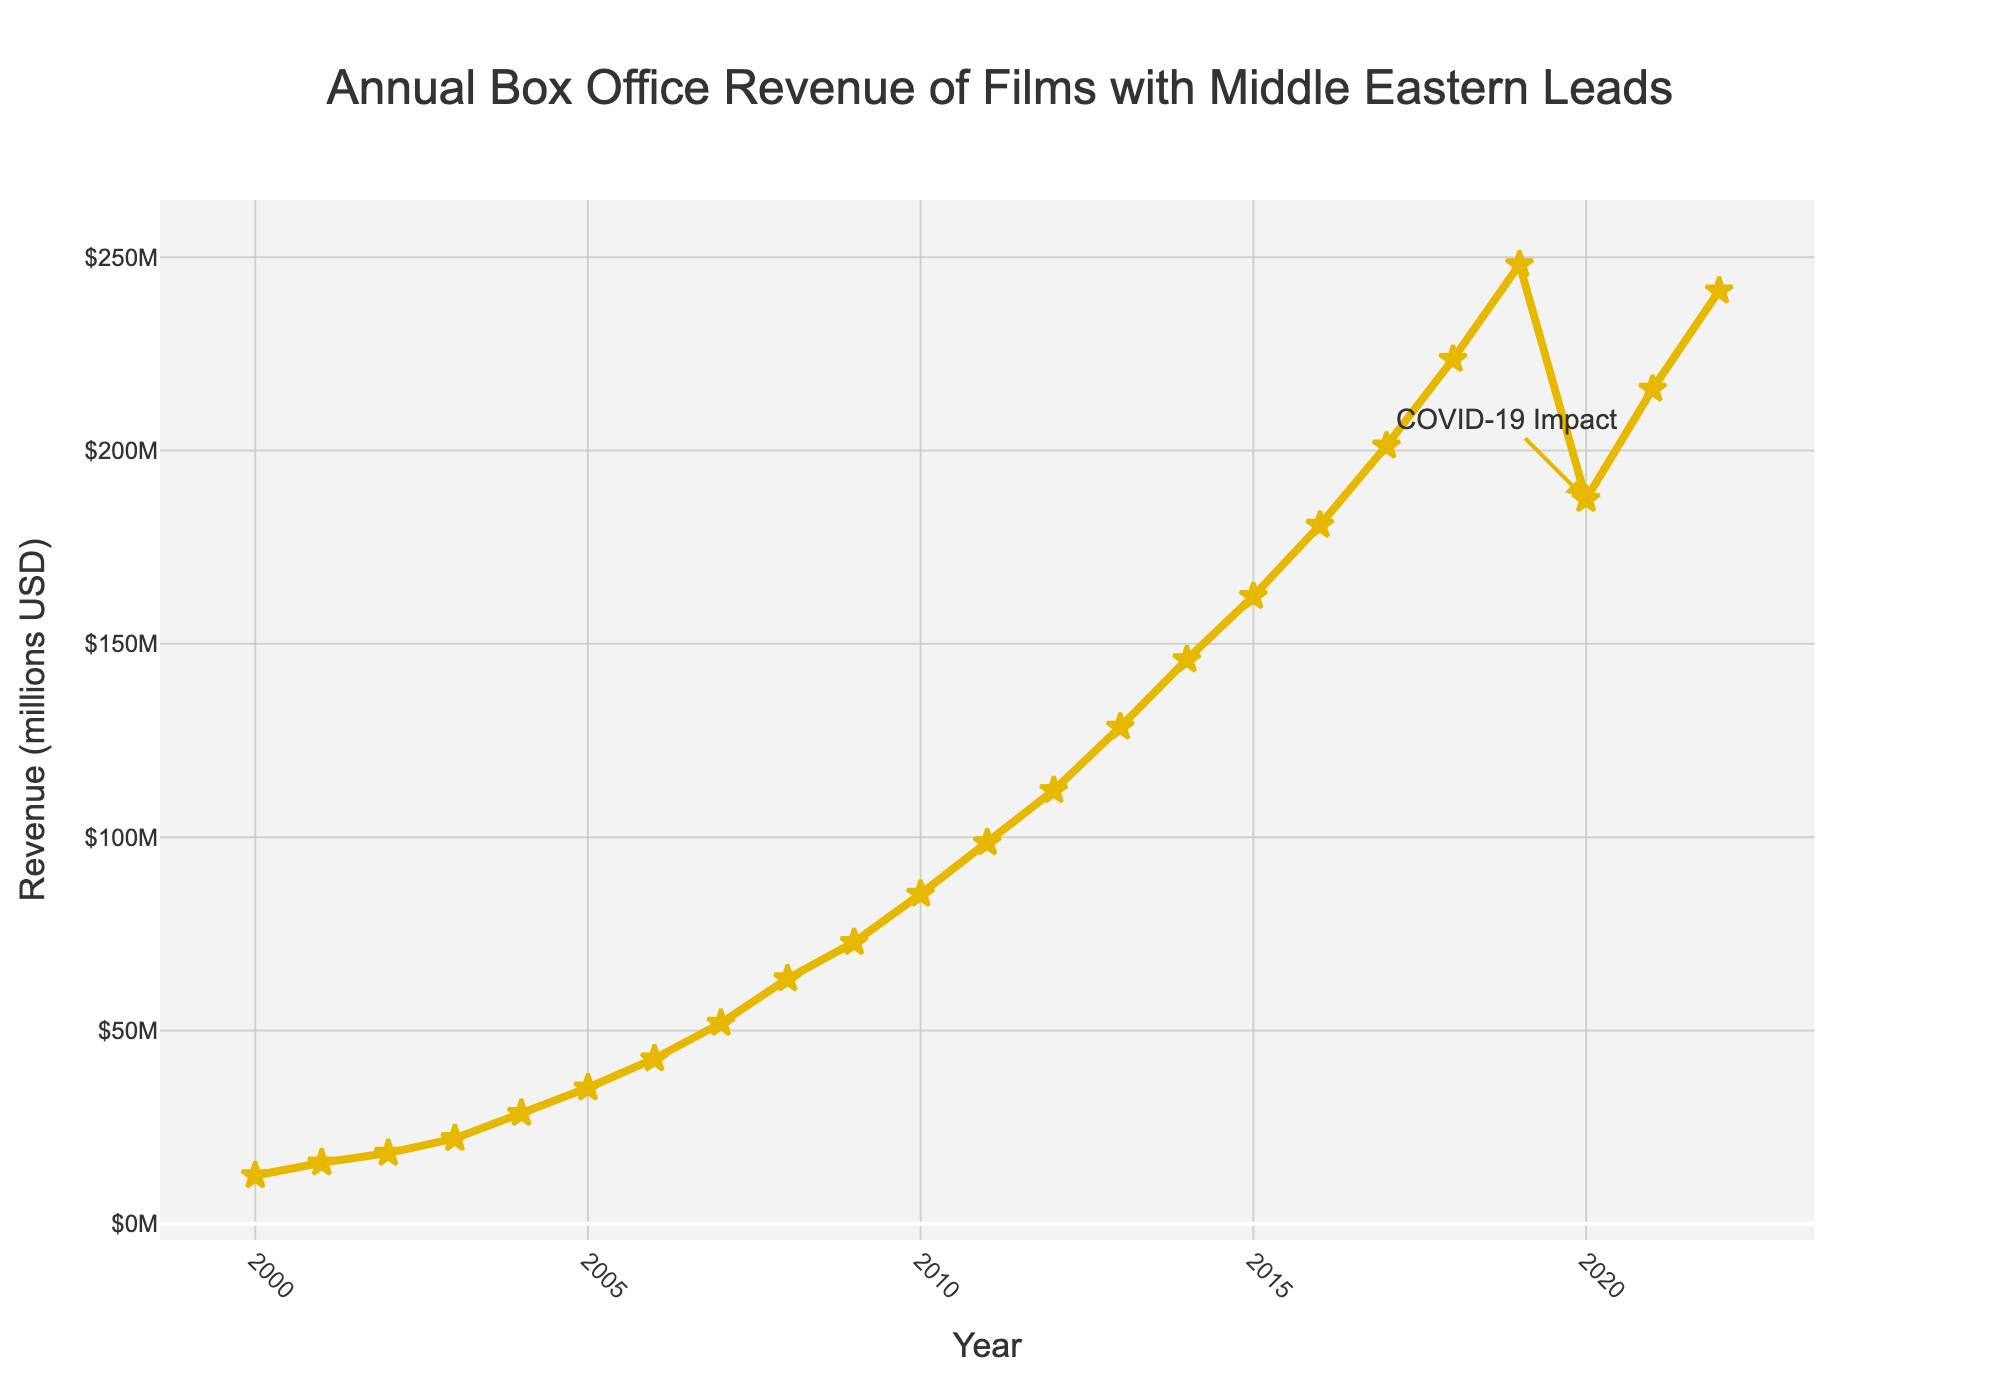What is the general trend in the annual box office revenue of films featuring Middle Eastern actors in leading roles from 2000 to 2022? The visual shows an upward trend, especially evident between 2000 and 2019, followed by a dip in 2020, and then a recovery in 2021 and 2022.
Answer: Upward trend Which year experienced the highest box office revenue? By visually inspecting the plotted points and labels, the year 2019 had the highest revenue at 248.1 million USD.
Answer: 2019 How did the box office revenue change from 2019 to 2020? The plot shows a decrease from 248.1 million USD in 2019 to 187.4 million USD in 2020. The annotation "COVID-19 Impact" also indicates a significant drop.
Answer: Decreased What was the percentage decrease in box office revenue from 2019 to 2020? To compute the percentage decrease: ((248.1 - 187.4) / 248.1) * 100. This equals approximately 24.4%.
Answer: 24.4% Compare the revenue growth between 2000-2010 and 2010-2020. Which period had faster growth? Calculate the difference: (85.3 - 12.5) for 2000-2010 and (187.4 - 85.3) for 2010-2020. The differences are 72.8 million (2000-2010) and 102.1 million (2010-2020), so the latter period had faster growth.
Answer: 2010-2020 What was the revenue in 2011, and how does it compare to 2021? The year 2011 shows a revenue of 98.6 million USD while 2021 has 215.9 million USD. 2021's revenue is significantly higher.
Answer: 215.9 million USD is higher than 98.6 million USD Identify the year in which the box office revenue exceeded 50 million USD for the first time and the revenue for that year. By tracing the curve, the year 2007 is the first to exceed 50 million USD, reaching 51.9 million USD.
Answer: 2007, 51.9 million USD How many years did it take for the box office revenue to double from its value in 2000? Revenue in 2000 was 12.5 million USD, and it doubled to 25 million USD by 2004, where the revenue was 28.6 million USD.
Answer: 4 years 